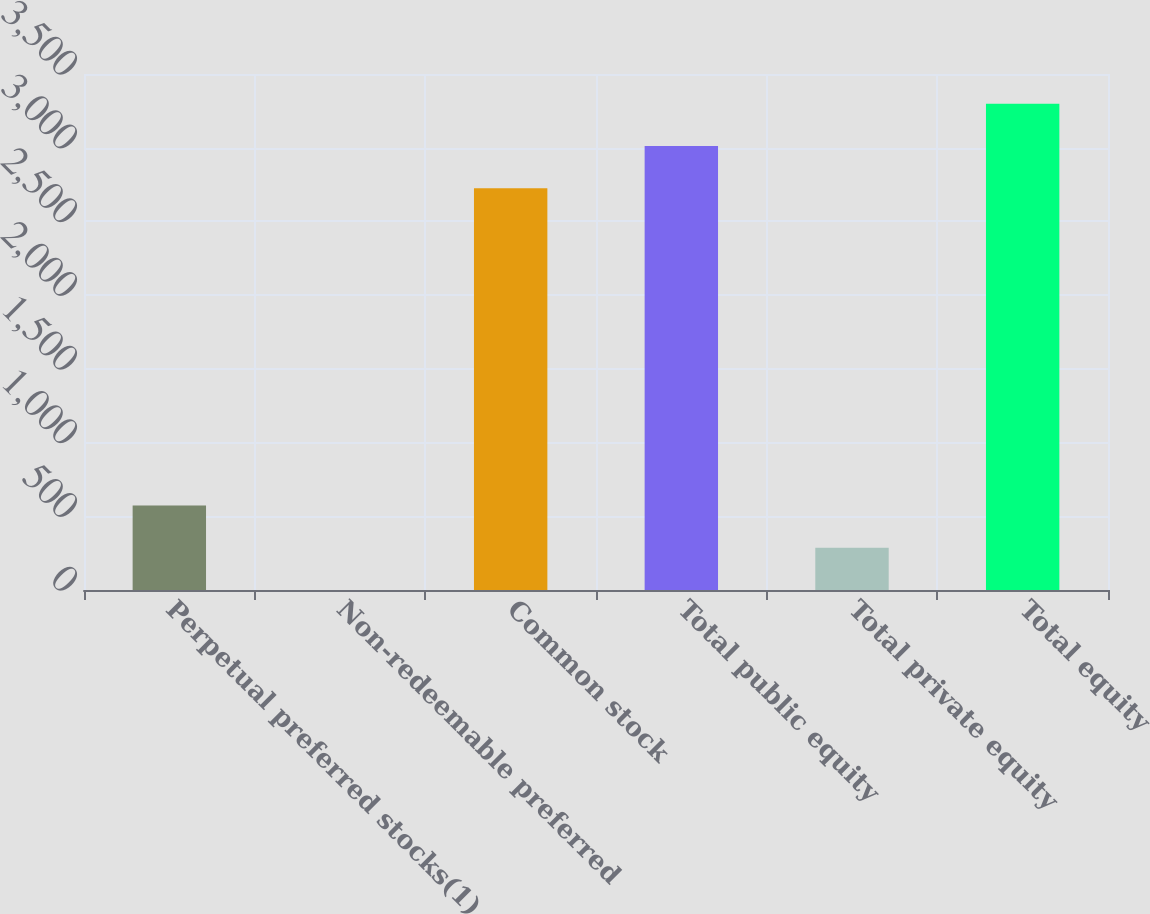Convert chart to OTSL. <chart><loc_0><loc_0><loc_500><loc_500><bar_chart><fcel>Perpetual preferred stocks(1)<fcel>Non-redeemable preferred<fcel>Common stock<fcel>Total public equity<fcel>Total private equity<fcel>Total equity<nl><fcel>573.12<fcel>0.4<fcel>2725<fcel>3011.36<fcel>286.76<fcel>3297.72<nl></chart> 